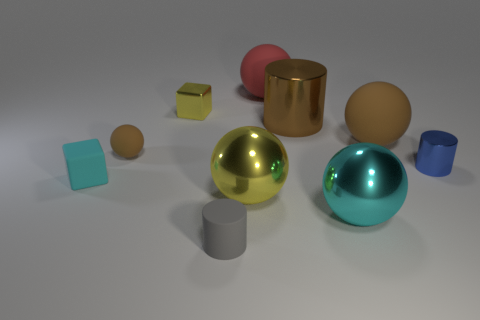Subtract 2 balls. How many balls are left? 3 Subtract all cylinders. How many objects are left? 7 Subtract all small blue objects. Subtract all large yellow balls. How many objects are left? 8 Add 2 gray cylinders. How many gray cylinders are left? 3 Add 10 gray metallic balls. How many gray metallic balls exist? 10 Subtract 0 purple cubes. How many objects are left? 10 